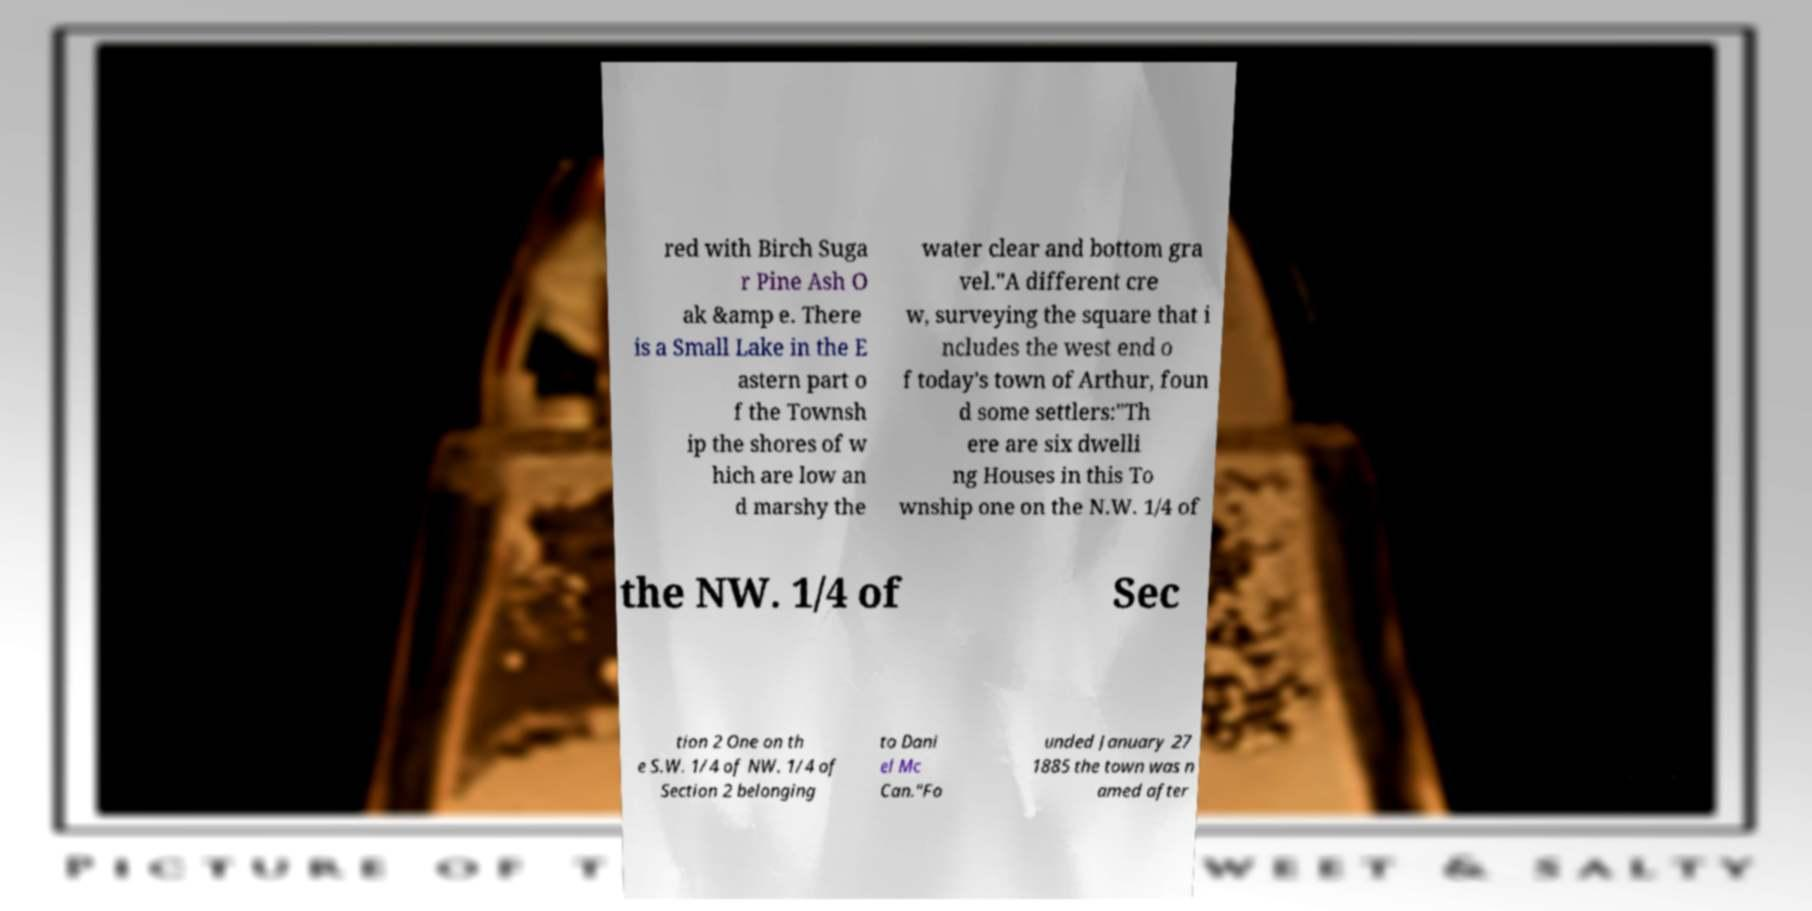Could you assist in decoding the text presented in this image and type it out clearly? red with Birch Suga r Pine Ash O ak &amp e. There is a Small Lake in the E astern part o f the Townsh ip the shores of w hich are low an d marshy the water clear and bottom gra vel."A different cre w, surveying the square that i ncludes the west end o f today's town of Arthur, foun d some settlers:"Th ere are six dwelli ng Houses in this To wnship one on the N.W. 1/4 of the NW. 1/4 of Sec tion 2 One on th e S.W. 1/4 of NW. 1/4 of Section 2 belonging to Dani el Mc Can."Fo unded January 27 1885 the town was n amed after 